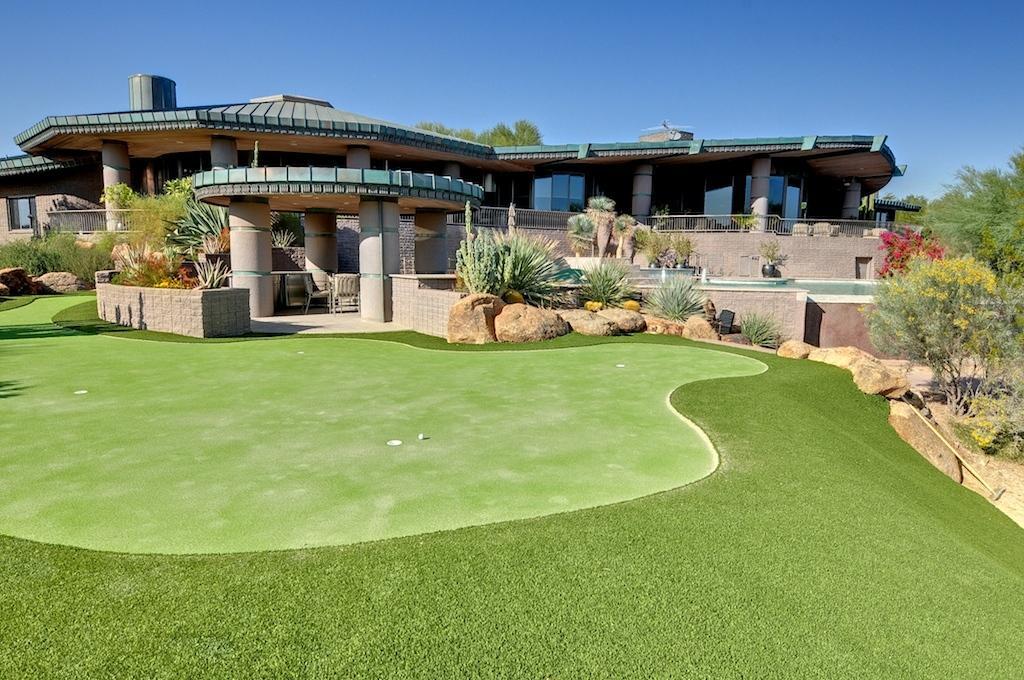Please provide a concise description of this image. In this image, we can see plants, trees, houses, pillars, walls, railings, chairs, stones, grass and glass objects. At the top of the image, there is the sky. 